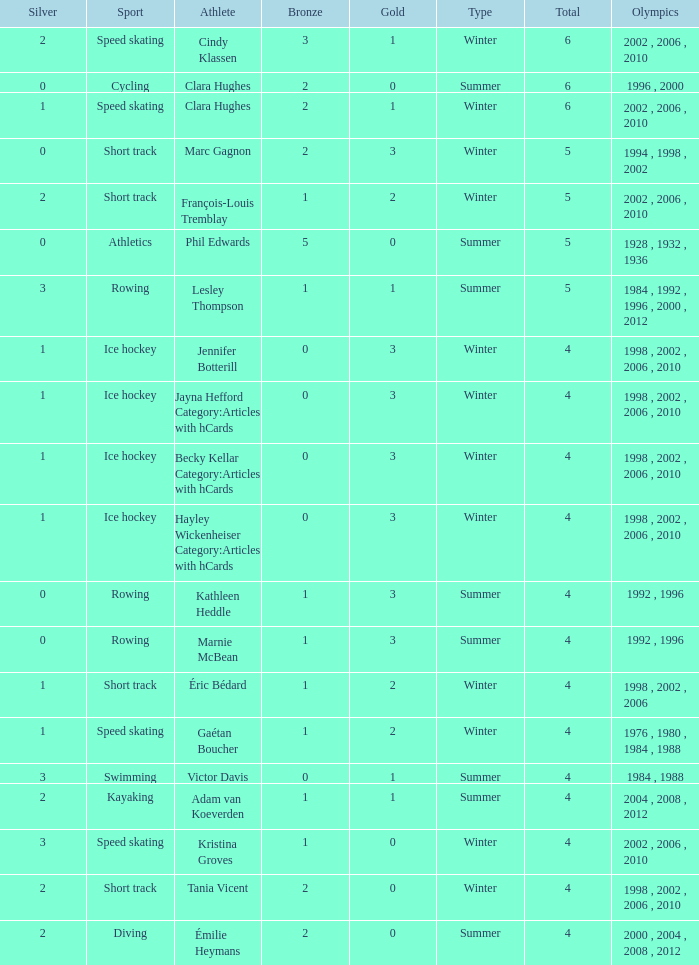What is the average gold of the winter athlete with 1 bronze, less than 3 silver, and less than 4 total medals? None. 